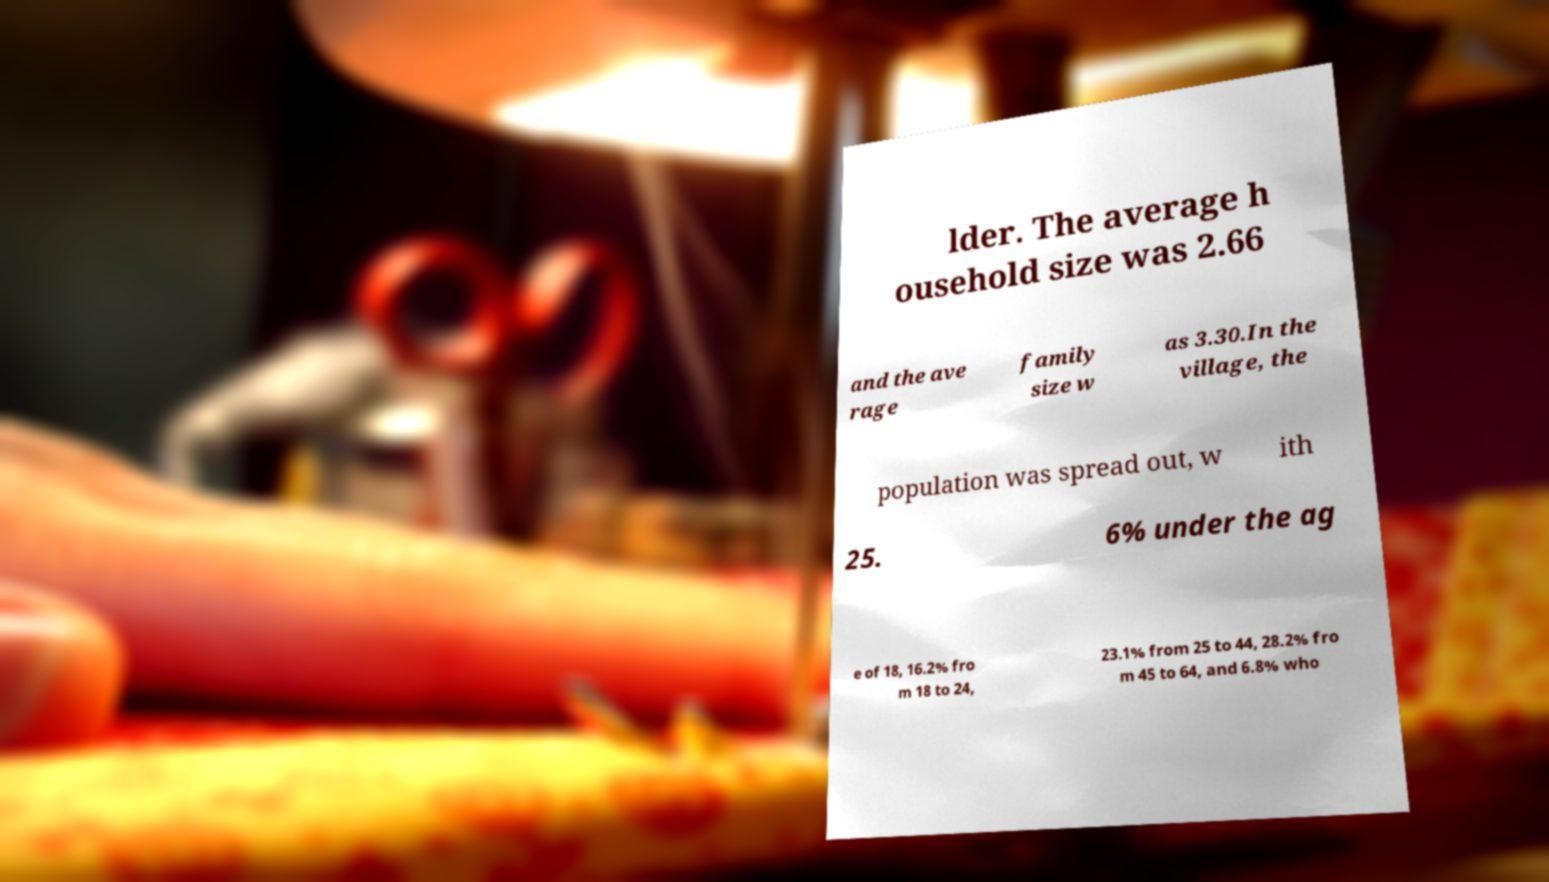Could you assist in decoding the text presented in this image and type it out clearly? lder. The average h ousehold size was 2.66 and the ave rage family size w as 3.30.In the village, the population was spread out, w ith 25. 6% under the ag e of 18, 16.2% fro m 18 to 24, 23.1% from 25 to 44, 28.2% fro m 45 to 64, and 6.8% who 